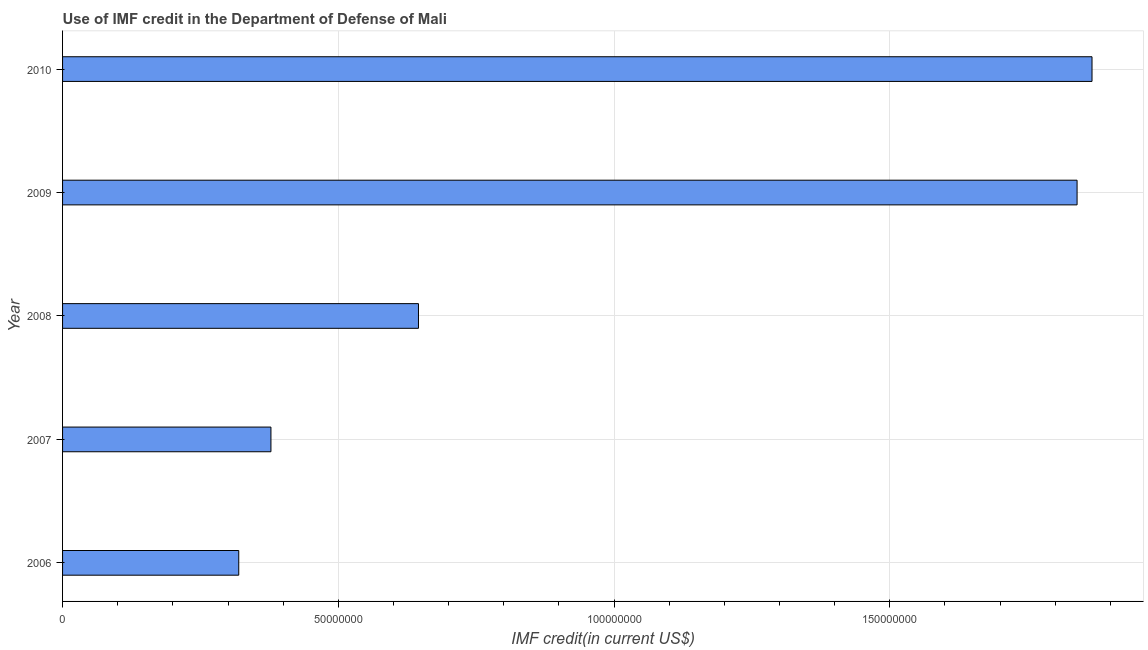Does the graph contain any zero values?
Give a very brief answer. No. Does the graph contain grids?
Give a very brief answer. Yes. What is the title of the graph?
Your answer should be compact. Use of IMF credit in the Department of Defense of Mali. What is the label or title of the X-axis?
Provide a succinct answer. IMF credit(in current US$). What is the label or title of the Y-axis?
Provide a short and direct response. Year. What is the use of imf credit in dod in 2009?
Your answer should be compact. 1.84e+08. Across all years, what is the maximum use of imf credit in dod?
Offer a very short reply. 1.87e+08. Across all years, what is the minimum use of imf credit in dod?
Offer a very short reply. 3.20e+07. What is the sum of the use of imf credit in dod?
Provide a succinct answer. 5.05e+08. What is the difference between the use of imf credit in dod in 2007 and 2008?
Provide a succinct answer. -2.68e+07. What is the average use of imf credit in dod per year?
Your answer should be compact. 1.01e+08. What is the median use of imf credit in dod?
Provide a succinct answer. 6.45e+07. What is the ratio of the use of imf credit in dod in 2007 to that in 2009?
Your response must be concise. 0.2. What is the difference between the highest and the second highest use of imf credit in dod?
Your answer should be very brief. 2.71e+06. Is the sum of the use of imf credit in dod in 2006 and 2009 greater than the maximum use of imf credit in dod across all years?
Your answer should be very brief. Yes. What is the difference between the highest and the lowest use of imf credit in dod?
Give a very brief answer. 1.55e+08. In how many years, is the use of imf credit in dod greater than the average use of imf credit in dod taken over all years?
Make the answer very short. 2. How many bars are there?
Your answer should be compact. 5. What is the difference between two consecutive major ticks on the X-axis?
Your answer should be compact. 5.00e+07. Are the values on the major ticks of X-axis written in scientific E-notation?
Your response must be concise. No. What is the IMF credit(in current US$) in 2006?
Offer a very short reply. 3.20e+07. What is the IMF credit(in current US$) in 2007?
Your response must be concise. 3.78e+07. What is the IMF credit(in current US$) in 2008?
Your response must be concise. 6.45e+07. What is the IMF credit(in current US$) in 2009?
Your answer should be compact. 1.84e+08. What is the IMF credit(in current US$) of 2010?
Give a very brief answer. 1.87e+08. What is the difference between the IMF credit(in current US$) in 2006 and 2007?
Your response must be concise. -5.84e+06. What is the difference between the IMF credit(in current US$) in 2006 and 2008?
Provide a succinct answer. -3.26e+07. What is the difference between the IMF credit(in current US$) in 2006 and 2009?
Offer a terse response. -1.52e+08. What is the difference between the IMF credit(in current US$) in 2006 and 2010?
Your response must be concise. -1.55e+08. What is the difference between the IMF credit(in current US$) in 2007 and 2008?
Your answer should be compact. -2.68e+07. What is the difference between the IMF credit(in current US$) in 2007 and 2009?
Your answer should be compact. -1.46e+08. What is the difference between the IMF credit(in current US$) in 2007 and 2010?
Your response must be concise. -1.49e+08. What is the difference between the IMF credit(in current US$) in 2008 and 2009?
Make the answer very short. -1.19e+08. What is the difference between the IMF credit(in current US$) in 2008 and 2010?
Ensure brevity in your answer.  -1.22e+08. What is the difference between the IMF credit(in current US$) in 2009 and 2010?
Your response must be concise. -2.71e+06. What is the ratio of the IMF credit(in current US$) in 2006 to that in 2007?
Offer a terse response. 0.85. What is the ratio of the IMF credit(in current US$) in 2006 to that in 2008?
Make the answer very short. 0.49. What is the ratio of the IMF credit(in current US$) in 2006 to that in 2009?
Give a very brief answer. 0.17. What is the ratio of the IMF credit(in current US$) in 2006 to that in 2010?
Keep it short and to the point. 0.17. What is the ratio of the IMF credit(in current US$) in 2007 to that in 2008?
Offer a very short reply. 0.58. What is the ratio of the IMF credit(in current US$) in 2007 to that in 2009?
Give a very brief answer. 0.2. What is the ratio of the IMF credit(in current US$) in 2007 to that in 2010?
Offer a terse response. 0.2. What is the ratio of the IMF credit(in current US$) in 2008 to that in 2009?
Your answer should be very brief. 0.35. What is the ratio of the IMF credit(in current US$) in 2008 to that in 2010?
Offer a terse response. 0.35. 